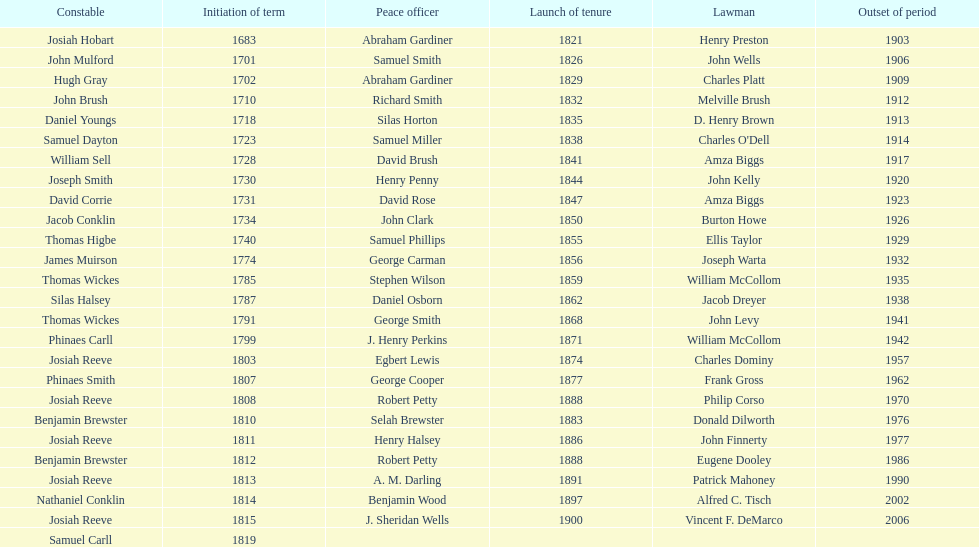Who was the sheriff in suffolk county before amza biggs first term there as sheriff? Charles O'Dell. 